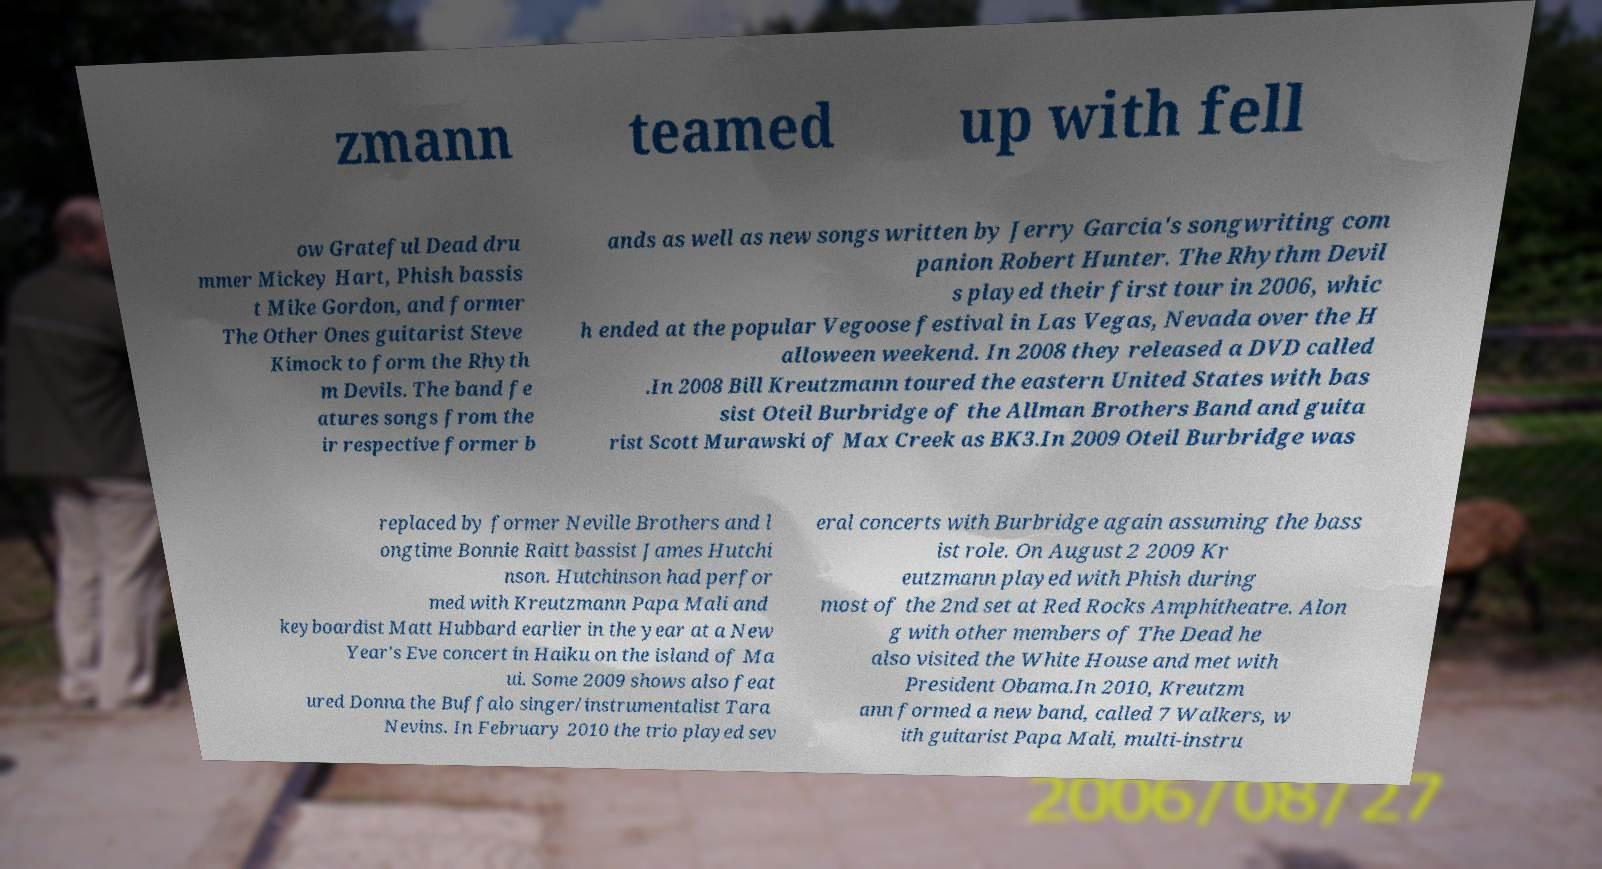Please identify and transcribe the text found in this image. zmann teamed up with fell ow Grateful Dead dru mmer Mickey Hart, Phish bassis t Mike Gordon, and former The Other Ones guitarist Steve Kimock to form the Rhyth m Devils. The band fe atures songs from the ir respective former b ands as well as new songs written by Jerry Garcia's songwriting com panion Robert Hunter. The Rhythm Devil s played their first tour in 2006, whic h ended at the popular Vegoose festival in Las Vegas, Nevada over the H alloween weekend. In 2008 they released a DVD called .In 2008 Bill Kreutzmann toured the eastern United States with bas sist Oteil Burbridge of the Allman Brothers Band and guita rist Scott Murawski of Max Creek as BK3.In 2009 Oteil Burbridge was replaced by former Neville Brothers and l ongtime Bonnie Raitt bassist James Hutchi nson. Hutchinson had perfor med with Kreutzmann Papa Mali and keyboardist Matt Hubbard earlier in the year at a New Year's Eve concert in Haiku on the island of Ma ui. Some 2009 shows also feat ured Donna the Buffalo singer/instrumentalist Tara Nevins. In February 2010 the trio played sev eral concerts with Burbridge again assuming the bass ist role. On August 2 2009 Kr eutzmann played with Phish during most of the 2nd set at Red Rocks Amphitheatre. Alon g with other members of The Dead he also visited the White House and met with President Obama.In 2010, Kreutzm ann formed a new band, called 7 Walkers, w ith guitarist Papa Mali, multi-instru 